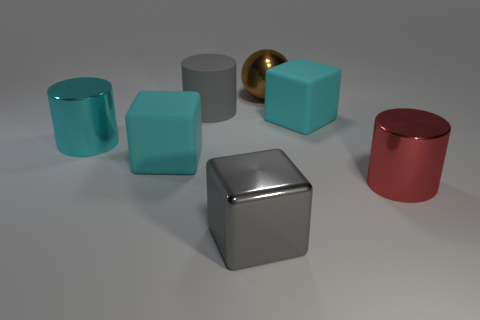Do the brown sphere and the red object have the same size?
Your answer should be compact. Yes. Is there a cyan matte thing that has the same size as the cyan metallic cylinder?
Ensure brevity in your answer.  Yes. What material is the big cylinder that is in front of the big cyan metal cylinder?
Offer a terse response. Metal. There is a large ball that is made of the same material as the big gray cube; what is its color?
Make the answer very short. Brown. What number of metallic objects are either large green things or cyan things?
Provide a short and direct response. 1. There is a cyan metallic object that is the same size as the gray matte object; what is its shape?
Ensure brevity in your answer.  Cylinder. What number of things are either things on the left side of the metallic cube or large blocks in front of the large cyan metal object?
Give a very brief answer. 4. What material is the red thing that is the same size as the brown shiny object?
Your answer should be compact. Metal. What number of other objects are there of the same material as the big cyan cylinder?
Provide a succinct answer. 3. Are there the same number of large gray blocks that are in front of the brown ball and metallic objects on the left side of the gray metal block?
Offer a terse response. Yes. 